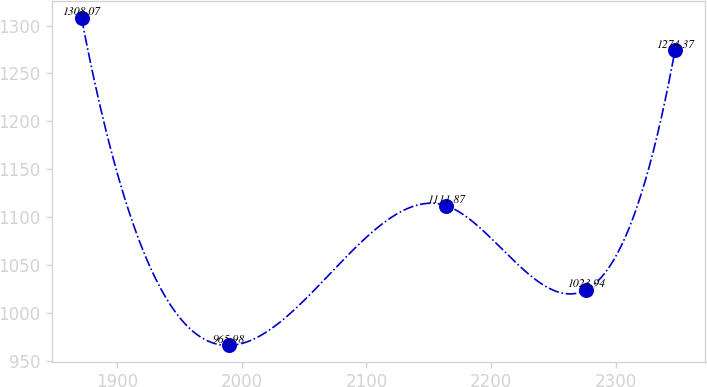<chart> <loc_0><loc_0><loc_500><loc_500><line_chart><ecel><fcel>Unnamed: 1<nl><fcel>1871.7<fcel>1308.07<nl><fcel>1989.63<fcel>965.98<nl><fcel>2163.84<fcel>1111.87<nl><fcel>2275.8<fcel>1023.94<nl><fcel>2347.2<fcel>1274.37<nl></chart> 